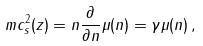<formula> <loc_0><loc_0><loc_500><loc_500>m c _ { s } ^ { 2 } ( z ) = n \frac { \partial } { \partial n } \mu ( n ) = \gamma \mu ( n ) \, ,</formula> 